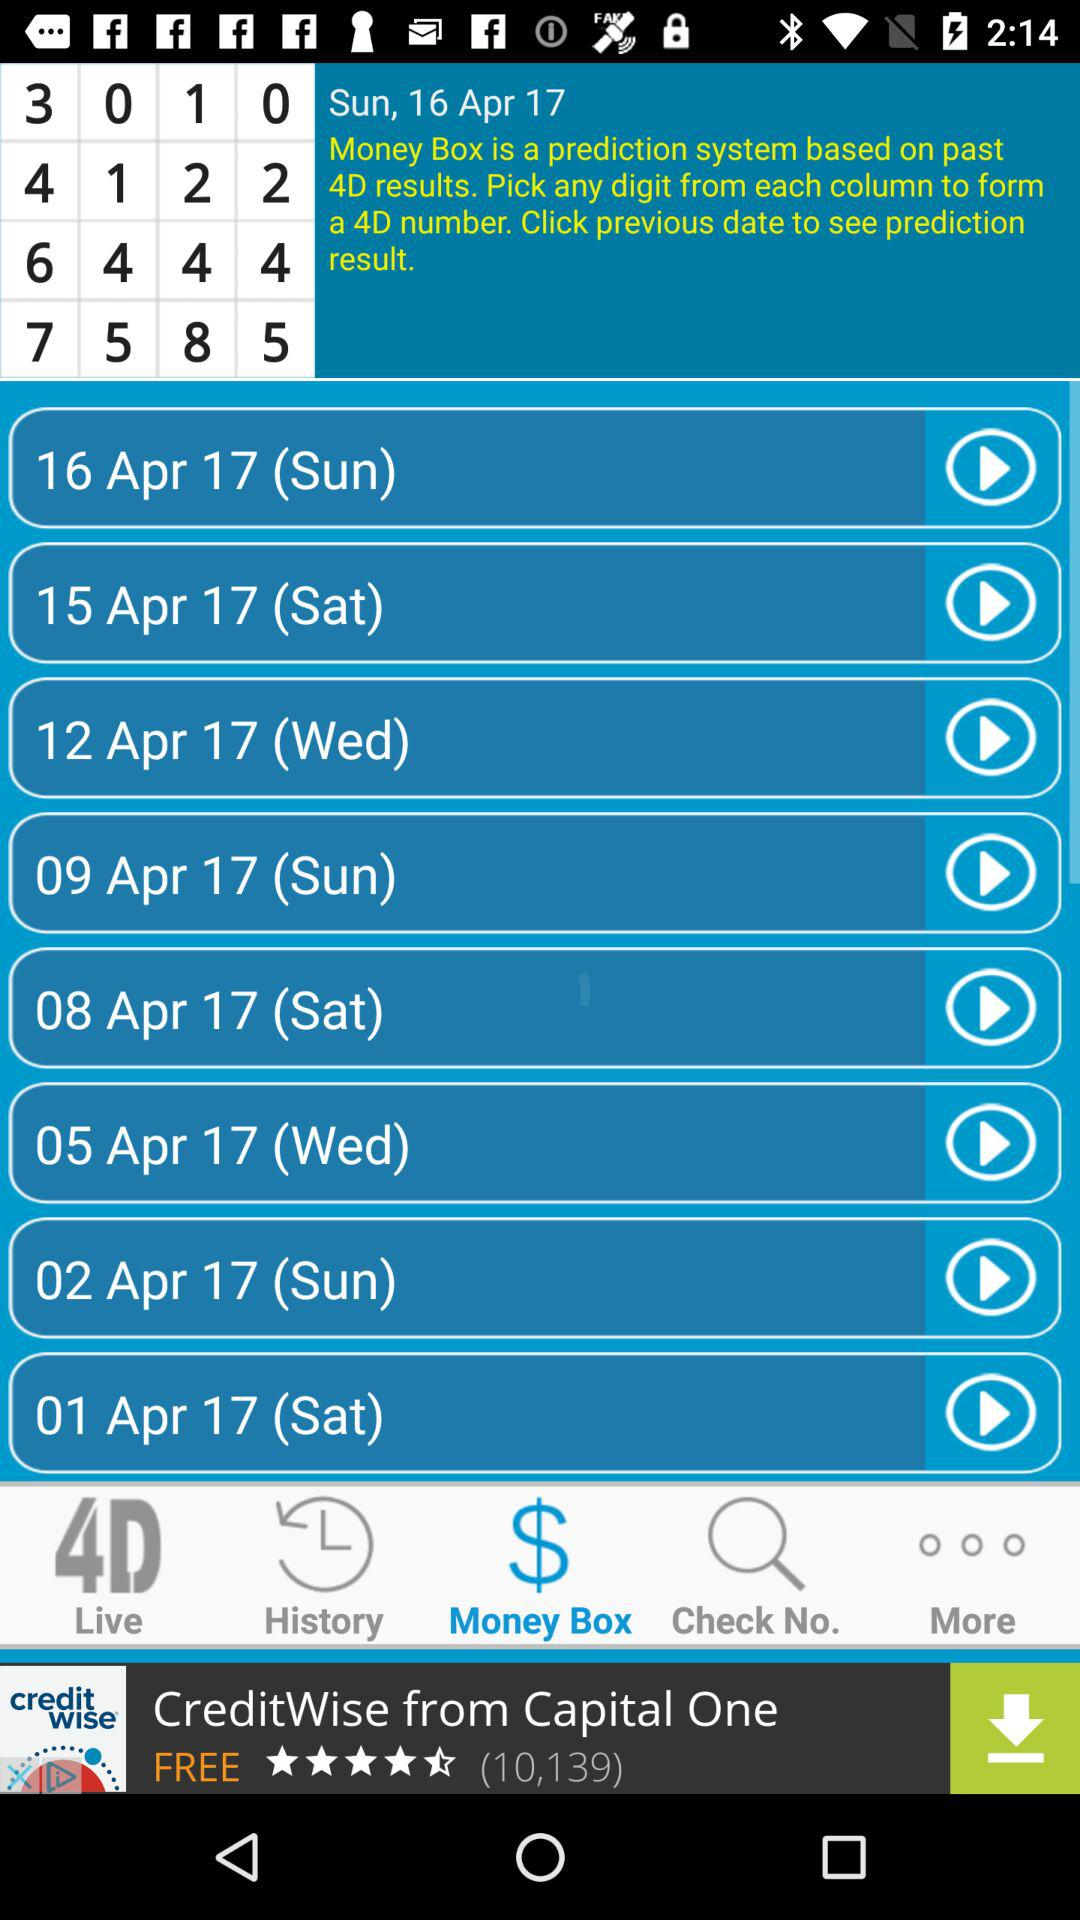What is the mentioned date? The mentioned dates are Sunday, April 16, 2017; Saturday, April 15, 2017; Wednesday, April 12, 2017; Sunday, April 9, 2017; Saturday, April 8, 2017; Wednesday, April 5, 2017; Sunday, April 2, 2017 and Saturday, April 1,2017. 